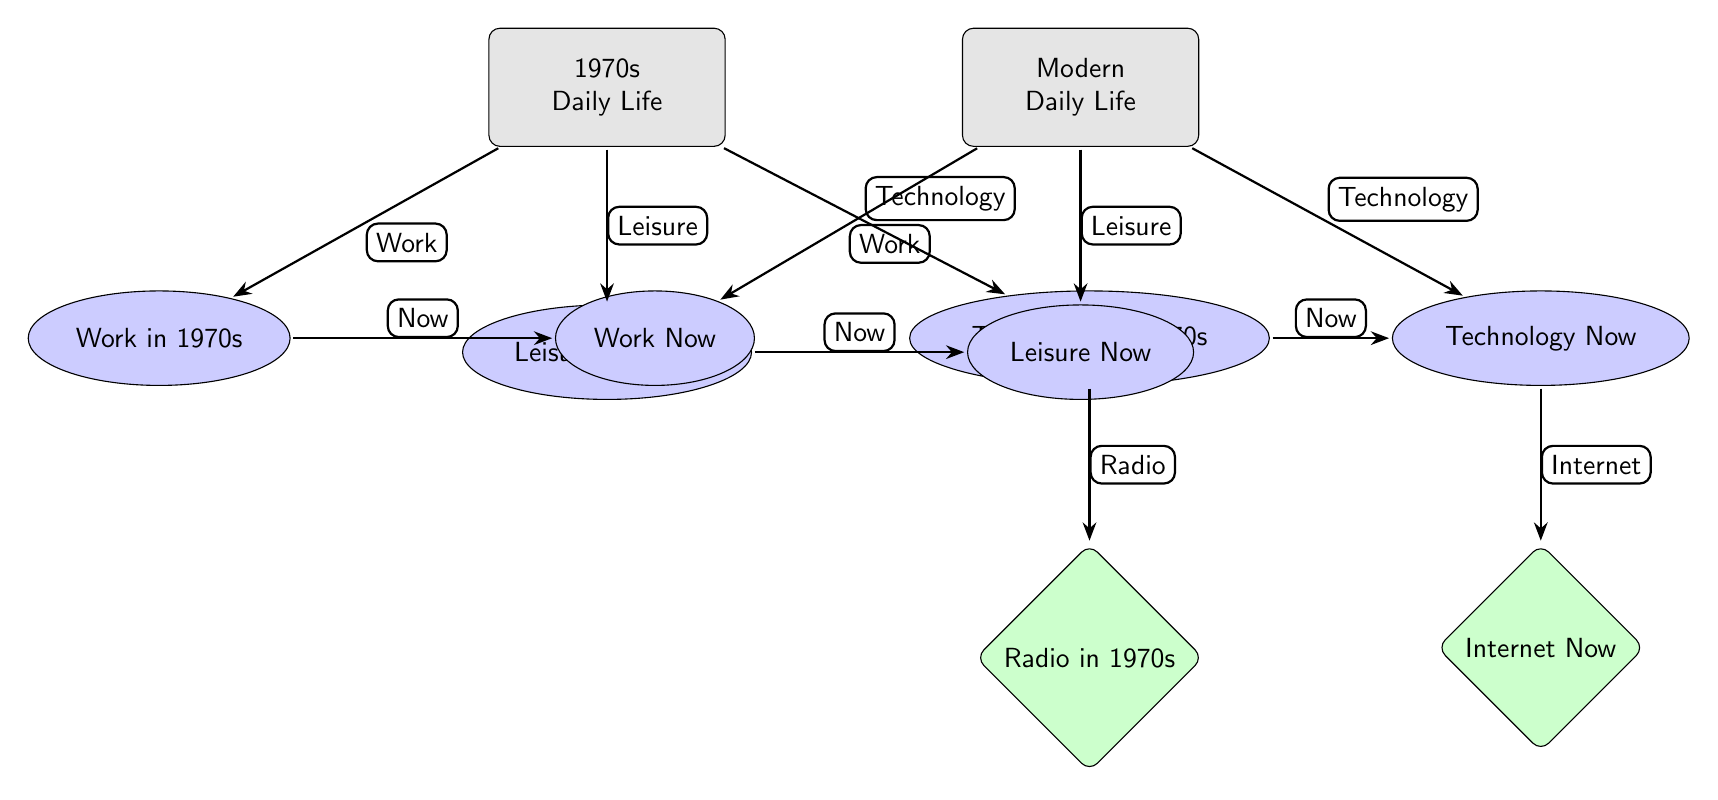What is the main focus of the left column in the diagram? The left column of the diagram is labeled "1970s Daily Life" and includes categories related to work, leisure, and technology specific to the 1970s.
Answer: 1970s Daily Life How many categories are presented under "1970s Daily Life"? There are three categories listed under "1970s Daily Life": Work in 1970s, Leisure in 1970s, and Technology in 1970s.
Answer: 3 What type of technology is associated with "Technology in 1970s"? The technology branch below "Technology in 1970s" specifically relates to Radio in 1970s.
Answer: Radio What is the relationship between "Leisure in 1970s" and "Leisure Now"? The diagram indicates that "Leisure in 1970s" has a direct arrow pointing to "Leisure Now," suggesting a link or change from past to present leisure activities.
Answer: Now Which technology is connected to "Technology Now"? The "Technology Now" node is connected to the "Internet Now" node, indicating that the focus is on the modern technological environment.
Answer: Internet How many nodes are associated with "Work"? There are two nodes associated with "Work": "Work in 1970s" and "Work Now."
Answer: 2 What does the arrow between "Tech70s" and "Radio in 1970s" indicate? The arrow indicates a relationship whereby "Technology in 1970s" specifically leads to "Radio in 1970s," highlighting the technology relevant to that era.
Answer: Radio How many total edges are present that connect the "1970s Daily Life" node to other nodes? The node "1970s Daily Life" connects to three categories: Work, Leisure, and Technology, making a total of three edges.
Answer: 3 Which era's daily life includes the node labeled "Internet Now"? "Internet Now" is part of the "Modern Daily Life" which represents current technological advancements in the modern era.
Answer: Modern Daily Life 